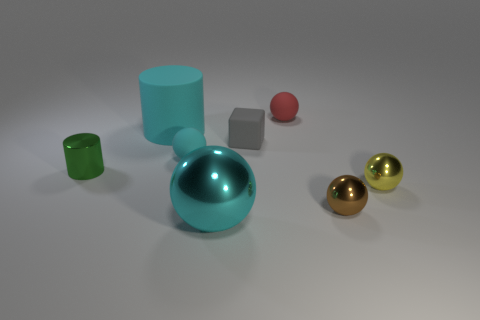How big is the matte ball that is to the left of the matte ball behind the gray cube?
Give a very brief answer. Small. The large thing in front of the green cylinder is what color?
Offer a terse response. Cyan. Are there any big blue matte things of the same shape as the small red rubber object?
Provide a succinct answer. No. Is the number of tiny red rubber things that are in front of the tiny green metal cylinder less than the number of tiny yellow metal things that are in front of the big metal thing?
Keep it short and to the point. No. The rubber cylinder is what color?
Your answer should be very brief. Cyan. There is a shiny ball that is on the left side of the small gray rubber object; is there a tiny gray block that is to the left of it?
Your response must be concise. No. How many red things have the same size as the brown metal ball?
Make the answer very short. 1. There is a matte ball that is to the left of the cyan ball in front of the shiny cylinder; how many small cyan spheres are behind it?
Your response must be concise. 0. How many small things are both to the right of the green thing and in front of the gray matte thing?
Your answer should be very brief. 3. Are there any other things that are the same color as the large ball?
Give a very brief answer. Yes. 